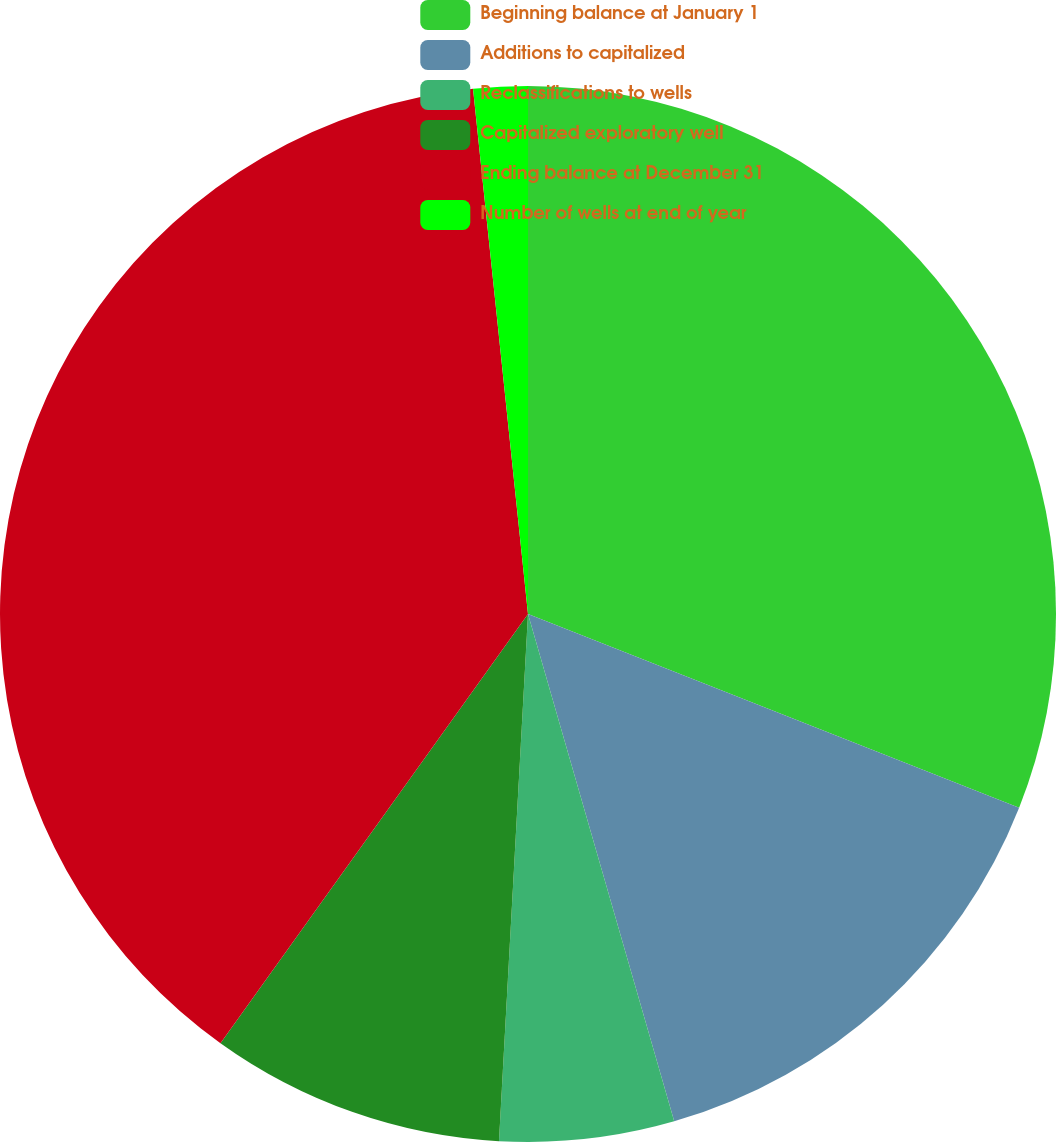Convert chart to OTSL. <chart><loc_0><loc_0><loc_500><loc_500><pie_chart><fcel>Beginning balance at January 1<fcel>Additions to capitalized<fcel>Reclassifications to wells<fcel>Capitalized exploratory well<fcel>Ending balance at December 31<fcel>Number of wells at end of year<nl><fcel>30.98%<fcel>14.55%<fcel>5.34%<fcel>9.02%<fcel>38.44%<fcel>1.66%<nl></chart> 